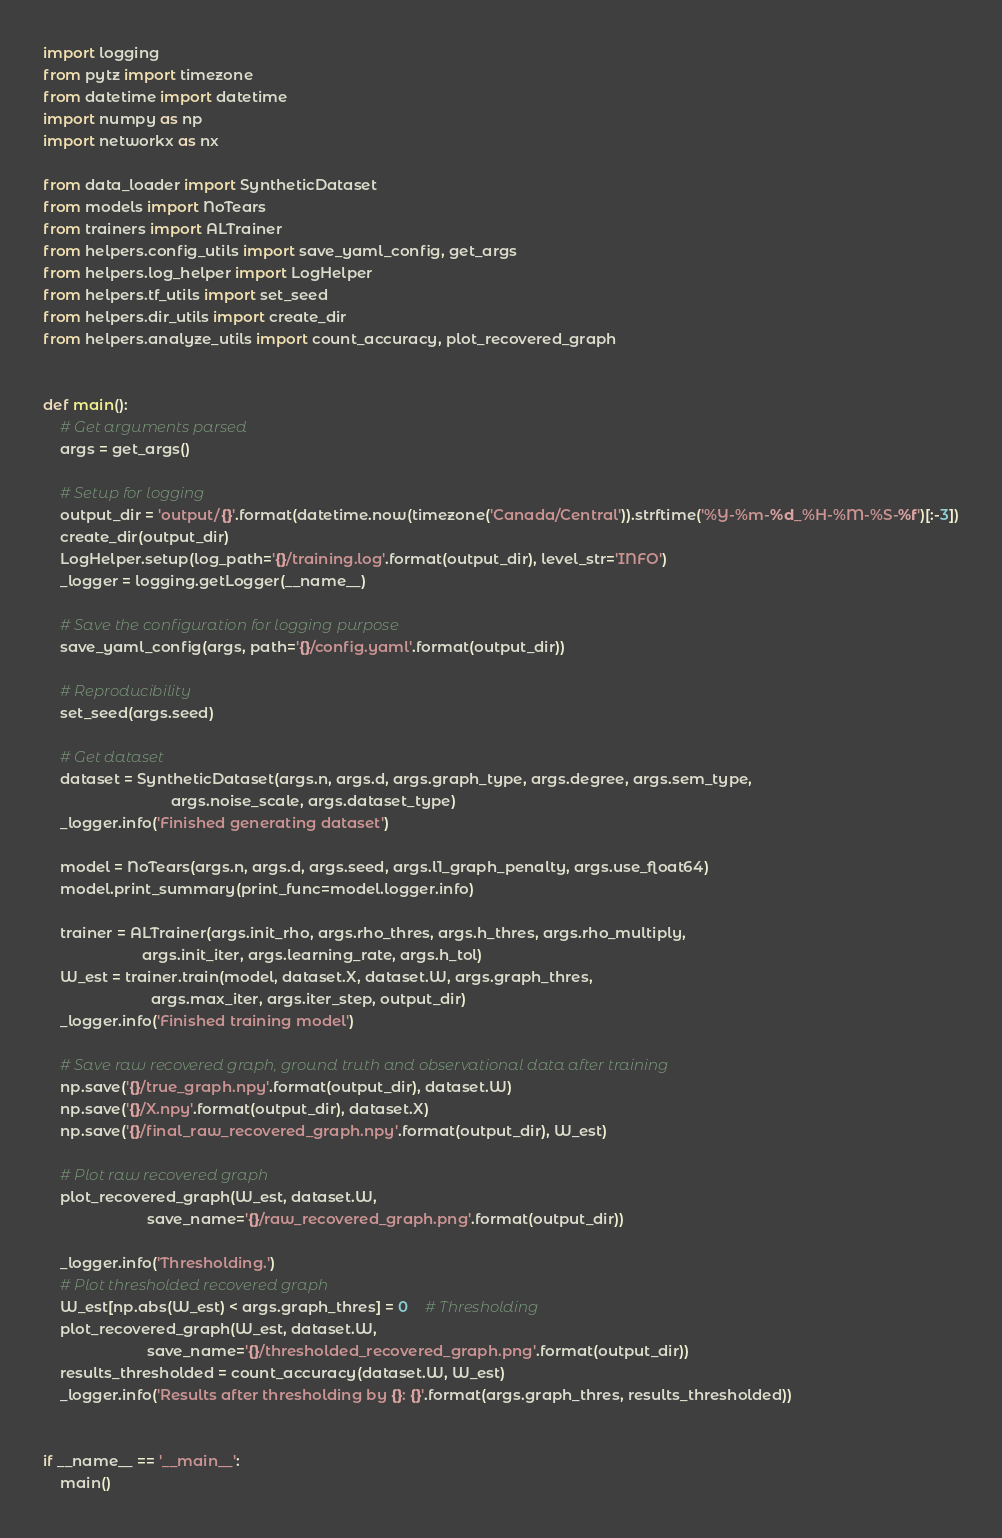<code> <loc_0><loc_0><loc_500><loc_500><_Python_>import logging
from pytz import timezone
from datetime import datetime
import numpy as np
import networkx as nx

from data_loader import SyntheticDataset
from models import NoTears
from trainers import ALTrainer
from helpers.config_utils import save_yaml_config, get_args
from helpers.log_helper import LogHelper
from helpers.tf_utils import set_seed
from helpers.dir_utils import create_dir
from helpers.analyze_utils import count_accuracy, plot_recovered_graph


def main():
    # Get arguments parsed
    args = get_args()

    # Setup for logging
    output_dir = 'output/{}'.format(datetime.now(timezone('Canada/Central')).strftime('%Y-%m-%d_%H-%M-%S-%f')[:-3])
    create_dir(output_dir)
    LogHelper.setup(log_path='{}/training.log'.format(output_dir), level_str='INFO')
    _logger = logging.getLogger(__name__)

    # Save the configuration for logging purpose
    save_yaml_config(args, path='{}/config.yaml'.format(output_dir))

    # Reproducibility
    set_seed(args.seed)

    # Get dataset
    dataset = SyntheticDataset(args.n, args.d, args.graph_type, args.degree, args.sem_type,
                               args.noise_scale, args.dataset_type)
    _logger.info('Finished generating dataset')

    model = NoTears(args.n, args.d, args.seed, args.l1_graph_penalty, args.use_float64)
    model.print_summary(print_func=model.logger.info)

    trainer = ALTrainer(args.init_rho, args.rho_thres, args.h_thres, args.rho_multiply,
                        args.init_iter, args.learning_rate, args.h_tol)
    W_est = trainer.train(model, dataset.X, dataset.W, args.graph_thres,
                          args.max_iter, args.iter_step, output_dir)
    _logger.info('Finished training model')

    # Save raw recovered graph, ground truth and observational data after training
    np.save('{}/true_graph.npy'.format(output_dir), dataset.W)
    np.save('{}/X.npy'.format(output_dir), dataset.X)
    np.save('{}/final_raw_recovered_graph.npy'.format(output_dir), W_est)

    # Plot raw recovered graph
    plot_recovered_graph(W_est, dataset.W,
                         save_name='{}/raw_recovered_graph.png'.format(output_dir))

    _logger.info('Thresholding.')
    # Plot thresholded recovered graph
    W_est[np.abs(W_est) < args.graph_thres] = 0    # Thresholding
    plot_recovered_graph(W_est, dataset.W,
                         save_name='{}/thresholded_recovered_graph.png'.format(output_dir))
    results_thresholded = count_accuracy(dataset.W, W_est)
    _logger.info('Results after thresholding by {}: {}'.format(args.graph_thres, results_thresholded))


if __name__ == '__main__':
    main()
</code> 